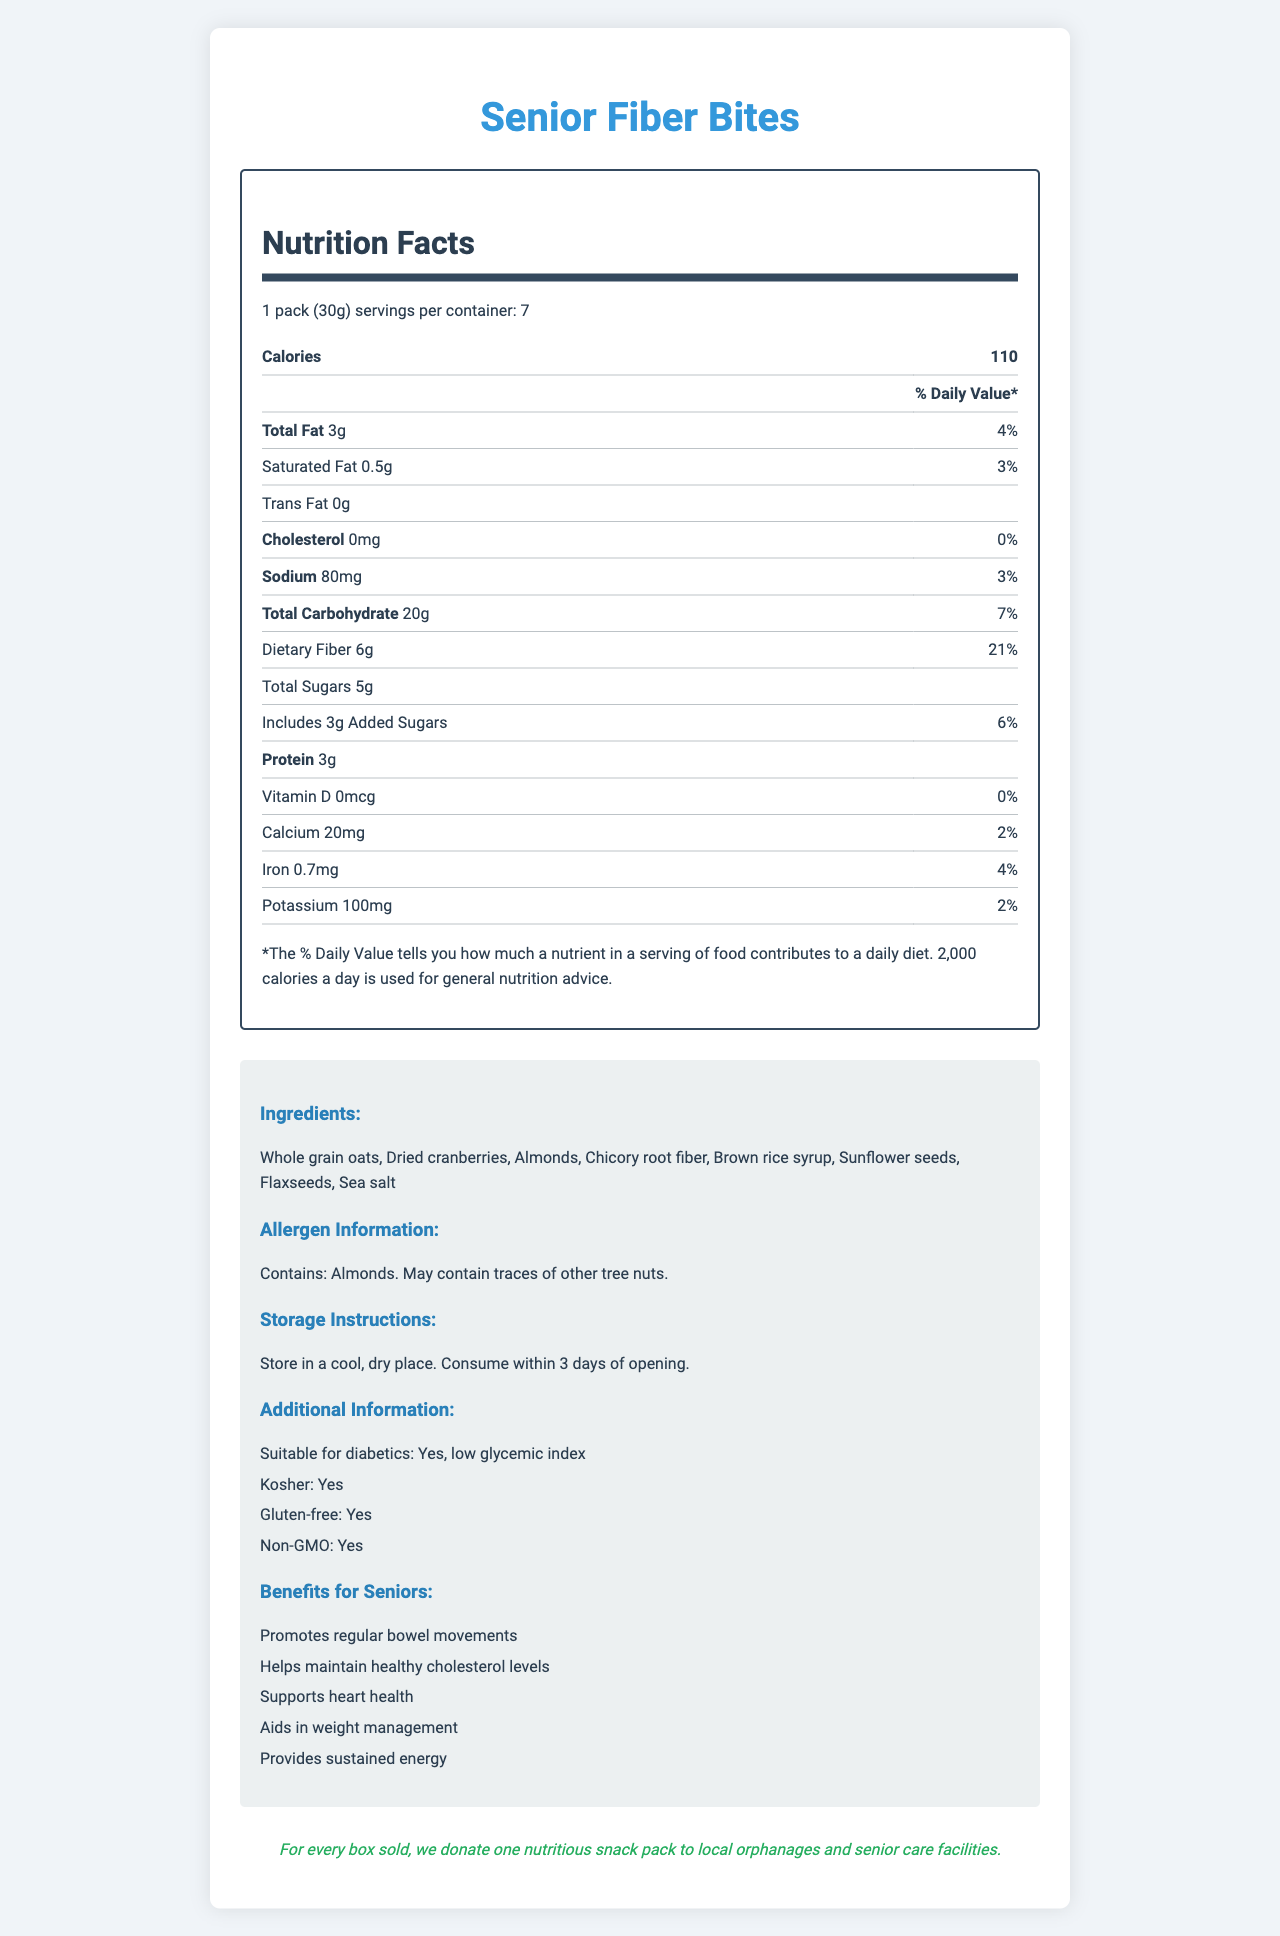what is the serving size? The serving size is clearly mentioned at the beginning of the nutrition information section.
Answer: 1 pack (30g) how many servings are in one container? The document states that there are 7 servings per container.
Answer: 7 what is the amount of dietary fiber in one serving? The dietary fiber content per serving is listed as 6g in the nutrition facts.
Answer: 6g what is the percentage of daily value for sodium? The sodium daily value percentage is shown as 3% in the nutrition section.
Answer: 3% what are the benefits of Senior Fiber Bites for seniors? The document lists these benefits under the "Benefits for Seniors" section.
Answer: Promotes regular bowel movements, Helps maintain healthy cholesterol levels, Supports heart health, Aids in weight management, Provides sustained energy how many grams of protein are in one serving? The protein content per serving is provided as 3g in the nutrition facts.
Answer: 3g are Senior Fiber Bites suitable for diabetics? The document states "Suitable for diabetics: Yes" in the additional information section.
Answer: Yes what ingredients are used in Senior Fiber Bites? The complete list of ingredients is provided in the "Ingredients" section of the document.
Answer: Whole grain oats, Dried cranberries, Almonds, Chicory root fiber, Brown rice syrup, Sunflower seeds, Flaxseeds, Sea salt how should the product be stored after opening? The storage instructions clearly state the conditions for storage and consumption after opening.
Answer: Store in a cool, dry place. Consume within 3 days of opening. which of the following are true about Senior Fiber Bites? A. Kosher B. Contains GMO C. Not suitable for diabetics The document mentions that the product is kosher, gluten-free, and non-GMO. It is also suitable for diabetics.
Answer: A what percentage of the daily value of calcium is provided by one serving? A. 2% B. 4% C. 6% D. 8% The daily value of calcium per serving is 2%, as stated in the nutrition facts.
Answer: A Senior Fiber Bites contain no trans fat. (True/False) The document lists "Trans Fat 0g" in the nutrition facts section, confirming there are no trans fats in the product.
Answer: True is there any information about the product's price in the document? The document does not provide any information regarding the price of the product.
Answer: Cannot be determined summarize the main idea of the document. The document aims to give comprehensive information about the Senior Fiber Bites, focusing on their nutrition, health benefits, and the charitable contribution linked with their purchase.
Answer: The document provides detailed nutrition facts and additional information about the Senior Fiber Bites, a fiber-rich snack designed for older adults. It includes serving size, daily values of various nutrients, ingredients, allergen information, storage instructions, and benefits for seniors. Additionally, it mentions the product's suitability for diabetics, kosher status, gluten-free nature, non-GMO status, and a charitable aspect where a nutritious snack pack is donated for every box sold. 